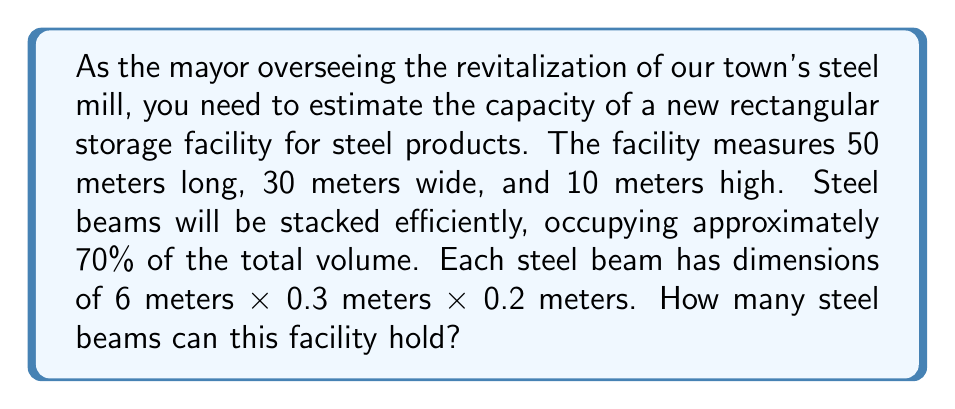What is the answer to this math problem? Let's approach this problem step-by-step:

1) First, calculate the total volume of the storage facility:
   $V_{total} = length \times width \times height$
   $V_{total} = 50 \text{ m} \times 30 \text{ m} \times 10 \text{ m} = 15,000 \text{ m}^3$

2) Given that the steel beams will occupy 70% of the total volume, calculate the usable volume:
   $V_{usable} = 70\% \times V_{total} = 0.7 \times 15,000 \text{ m}^3 = 10,500 \text{ m}^3$

3) Calculate the volume of a single steel beam:
   $V_{beam} = 6 \text{ m} \times 0.3 \text{ m} \times 0.2 \text{ m} = 0.36 \text{ m}^3$

4) To find the number of beams that can be stored, divide the usable volume by the volume of a single beam:
   $N_{beams} = \frac{V_{usable}}{V_{beam}} = \frac{10,500 \text{ m}^3}{0.36 \text{ m}^3} \approx 29,166.67$

5) Since we can't store a fraction of a beam, we round down to the nearest whole number:
   $N_{beams} = 29,166$

Therefore, the rectangular storage facility can hold 29,166 steel beams.
Answer: 29,166 steel beams 